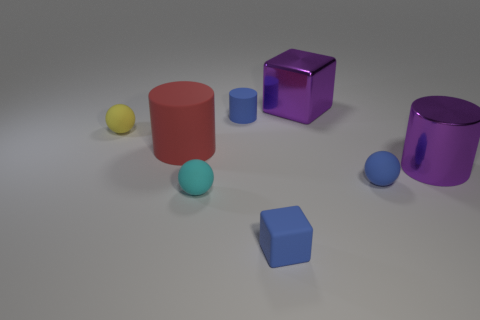Add 2 tiny gray objects. How many objects exist? 10 Subtract all cylinders. How many objects are left? 5 Subtract 0 gray cubes. How many objects are left? 8 Subtract all large purple cylinders. Subtract all large blue blocks. How many objects are left? 7 Add 6 cyan matte objects. How many cyan matte objects are left? 7 Add 5 blue objects. How many blue objects exist? 8 